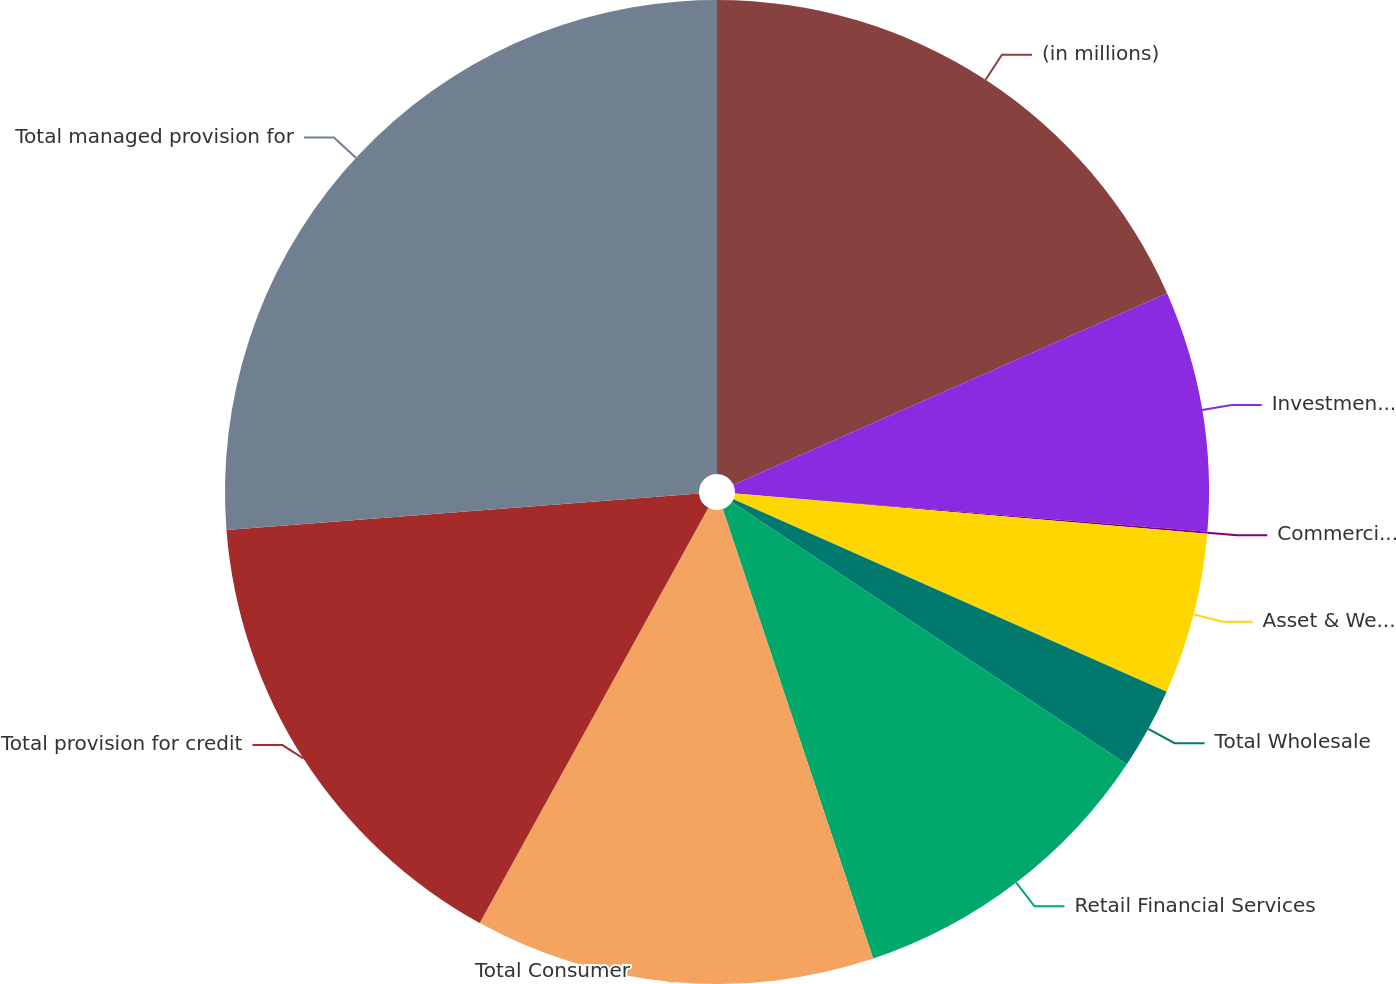Convert chart. <chart><loc_0><loc_0><loc_500><loc_500><pie_chart><fcel>(in millions)<fcel>Investment Bank<fcel>Commercial Banking<fcel>Asset & Wealth Management<fcel>Total Wholesale<fcel>Retail Financial Services<fcel>Total Consumer<fcel>Total provision for credit<fcel>Total managed provision for<nl><fcel>18.38%<fcel>7.91%<fcel>0.06%<fcel>5.3%<fcel>2.68%<fcel>10.53%<fcel>13.15%<fcel>15.76%<fcel>26.23%<nl></chart> 